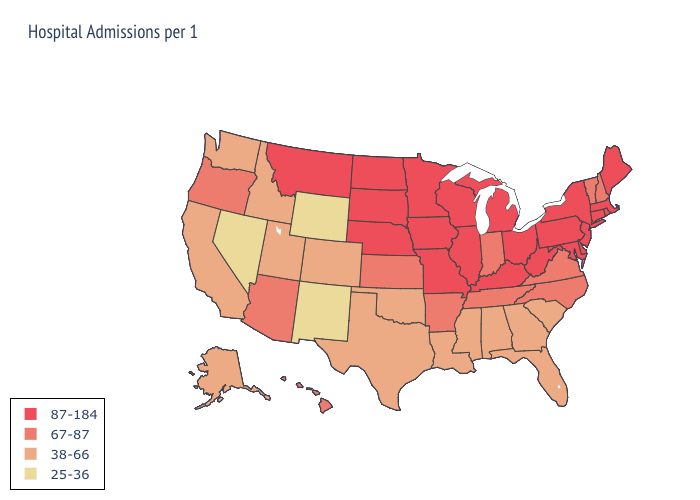Which states hav the highest value in the Northeast?
Answer briefly. Connecticut, Maine, Massachusetts, New Jersey, New York, Pennsylvania, Rhode Island. Name the states that have a value in the range 25-36?
Concise answer only. Nevada, New Mexico, Wyoming. What is the highest value in the West ?
Concise answer only. 87-184. Does North Carolina have the lowest value in the USA?
Write a very short answer. No. What is the value of North Dakota?
Write a very short answer. 87-184. Which states have the lowest value in the USA?
Concise answer only. Nevada, New Mexico, Wyoming. What is the value of Oklahoma?
Short answer required. 38-66. What is the value of Mississippi?
Quick response, please. 38-66. What is the value of Iowa?
Give a very brief answer. 87-184. Among the states that border Wyoming , does Nebraska have the lowest value?
Concise answer only. No. Is the legend a continuous bar?
Answer briefly. No. Among the states that border Alabama , which have the lowest value?
Keep it brief. Florida, Georgia, Mississippi. What is the highest value in the USA?
Keep it brief. 87-184. What is the lowest value in the South?
Keep it brief. 38-66. 